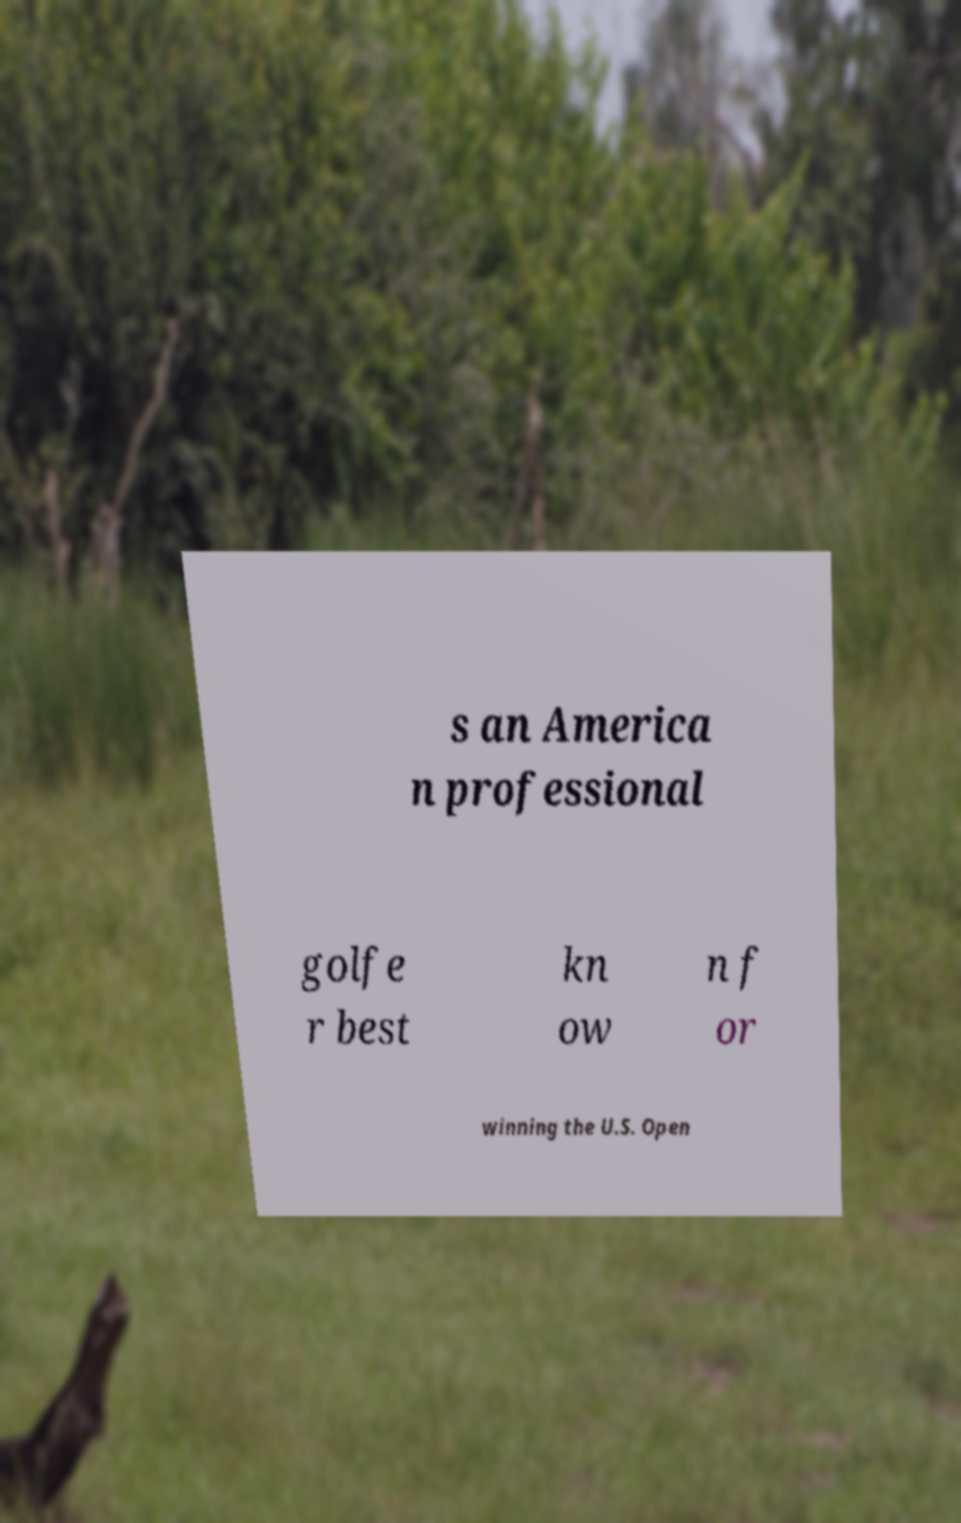Can you read and provide the text displayed in the image?This photo seems to have some interesting text. Can you extract and type it out for me? s an America n professional golfe r best kn ow n f or winning the U.S. Open 